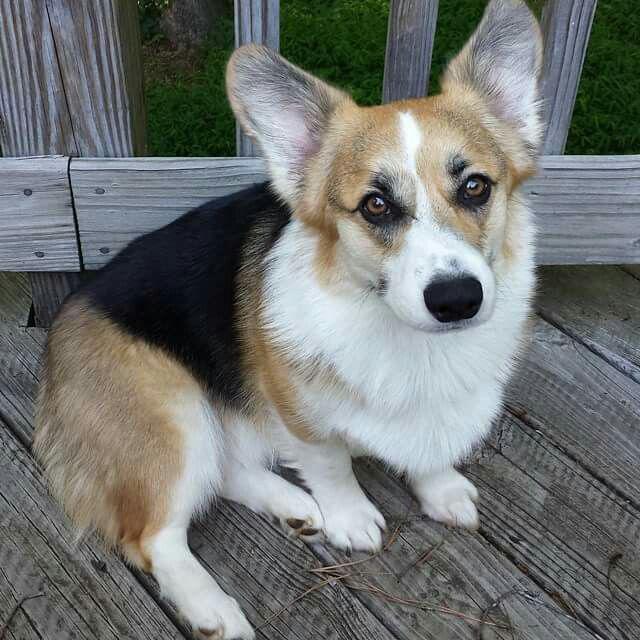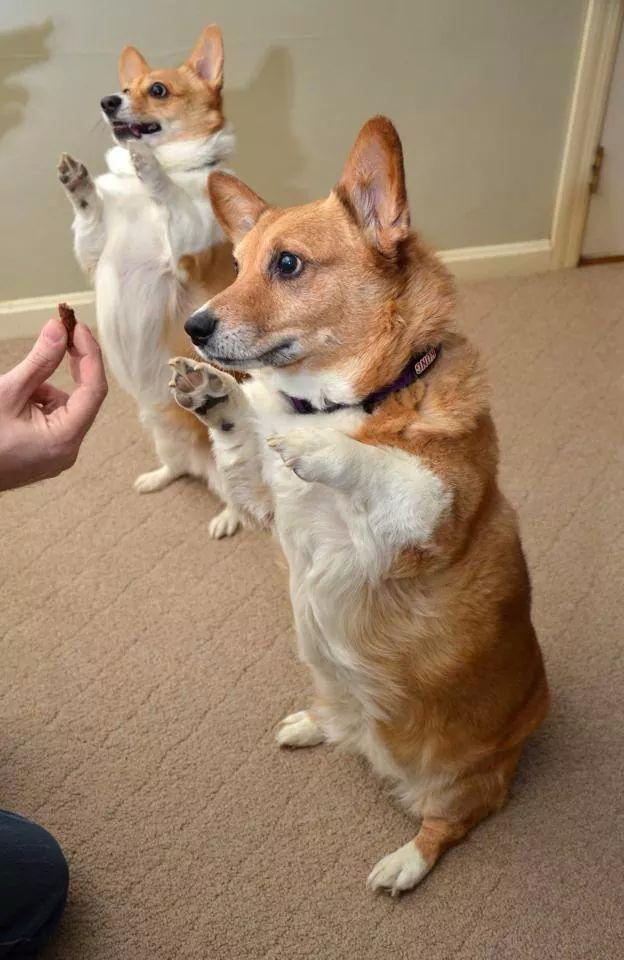The first image is the image on the left, the second image is the image on the right. For the images displayed, is the sentence "The dog in the image on the right is near a body of water." factually correct? Answer yes or no. No. The first image is the image on the left, the second image is the image on the right. For the images displayed, is the sentence "An image shows one orange-and-white corgi dog posed on the shore in front of water and looking at the camera." factually correct? Answer yes or no. No. 